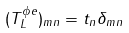Convert formula to latex. <formula><loc_0><loc_0><loc_500><loc_500>( T _ { L } ^ { \phi e } ) _ { m n } = t _ { n } \delta _ { m n }</formula> 